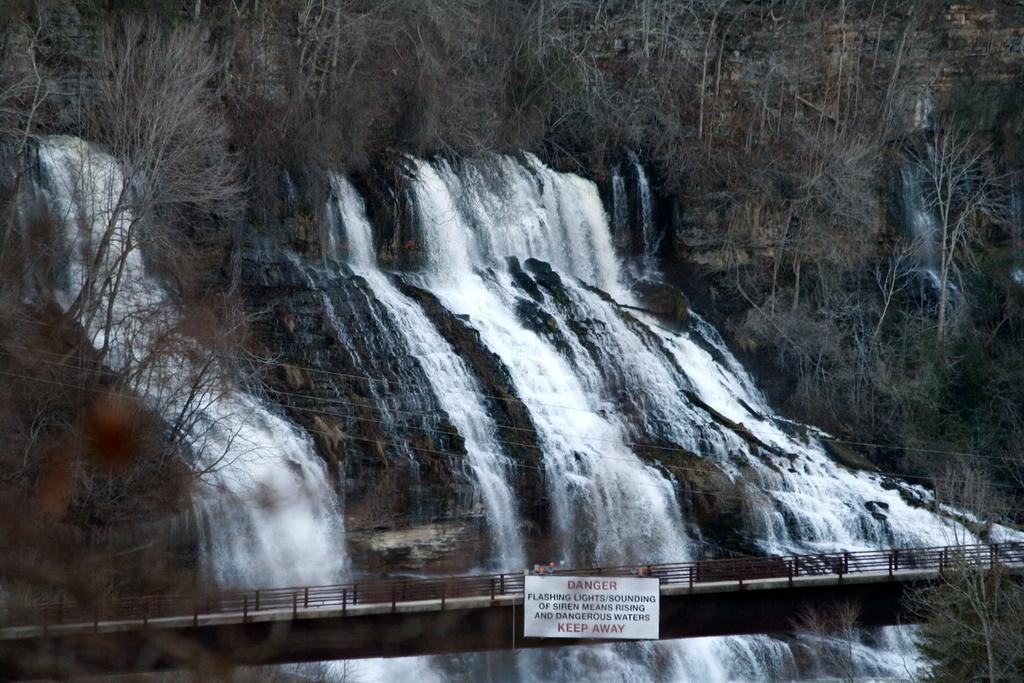What natural feature is the main subject of the image? There is a waterfall in the image. What is happening to the water in the image? Water is flowing in the image. What man-made structure can be seen in the image? There appears to be a bridge in the image. What is hanging in the image? There is a board hanging in the image. What type of vegetation is present in the image? Trees are present in the image. What street is visible in the image? There is no street visible in the image; it features a waterfall, a bridge, and trees. What type of work is being done on the waterfall in the image? There is no work being done on the waterfall in the image; it is a natural feature with water flowing over it. 